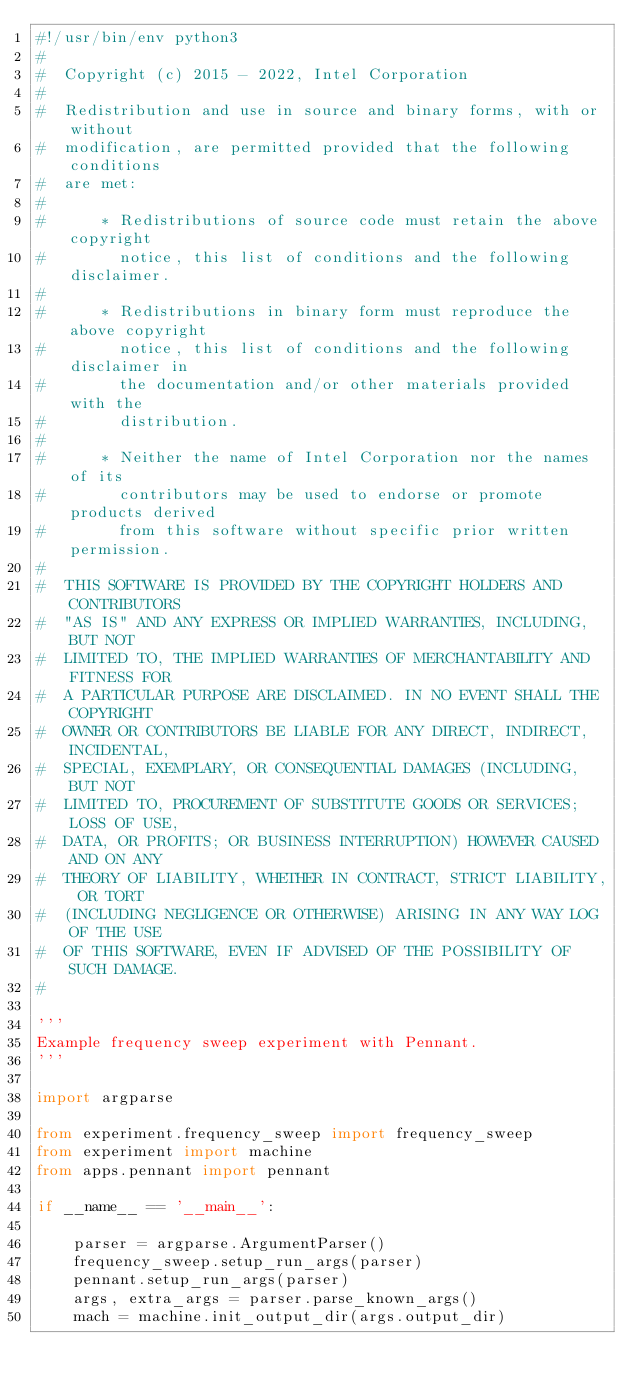Convert code to text. <code><loc_0><loc_0><loc_500><loc_500><_Python_>#!/usr/bin/env python3
#
#  Copyright (c) 2015 - 2022, Intel Corporation
#
#  Redistribution and use in source and binary forms, with or without
#  modification, are permitted provided that the following conditions
#  are met:
#
#      * Redistributions of source code must retain the above copyright
#        notice, this list of conditions and the following disclaimer.
#
#      * Redistributions in binary form must reproduce the above copyright
#        notice, this list of conditions and the following disclaimer in
#        the documentation and/or other materials provided with the
#        distribution.
#
#      * Neither the name of Intel Corporation nor the names of its
#        contributors may be used to endorse or promote products derived
#        from this software without specific prior written permission.
#
#  THIS SOFTWARE IS PROVIDED BY THE COPYRIGHT HOLDERS AND CONTRIBUTORS
#  "AS IS" AND ANY EXPRESS OR IMPLIED WARRANTIES, INCLUDING, BUT NOT
#  LIMITED TO, THE IMPLIED WARRANTIES OF MERCHANTABILITY AND FITNESS FOR
#  A PARTICULAR PURPOSE ARE DISCLAIMED. IN NO EVENT SHALL THE COPYRIGHT
#  OWNER OR CONTRIBUTORS BE LIABLE FOR ANY DIRECT, INDIRECT, INCIDENTAL,
#  SPECIAL, EXEMPLARY, OR CONSEQUENTIAL DAMAGES (INCLUDING, BUT NOT
#  LIMITED TO, PROCUREMENT OF SUBSTITUTE GOODS OR SERVICES; LOSS OF USE,
#  DATA, OR PROFITS; OR BUSINESS INTERRUPTION) HOWEVER CAUSED AND ON ANY
#  THEORY OF LIABILITY, WHETHER IN CONTRACT, STRICT LIABILITY, OR TORT
#  (INCLUDING NEGLIGENCE OR OTHERWISE) ARISING IN ANY WAY LOG OF THE USE
#  OF THIS SOFTWARE, EVEN IF ADVISED OF THE POSSIBILITY OF SUCH DAMAGE.
#

'''
Example frequency sweep experiment with Pennant.
'''

import argparse

from experiment.frequency_sweep import frequency_sweep
from experiment import machine
from apps.pennant import pennant

if __name__ == '__main__':

    parser = argparse.ArgumentParser()
    frequency_sweep.setup_run_args(parser)
    pennant.setup_run_args(parser)
    args, extra_args = parser.parse_known_args()
    mach = machine.init_output_dir(args.output_dir)</code> 